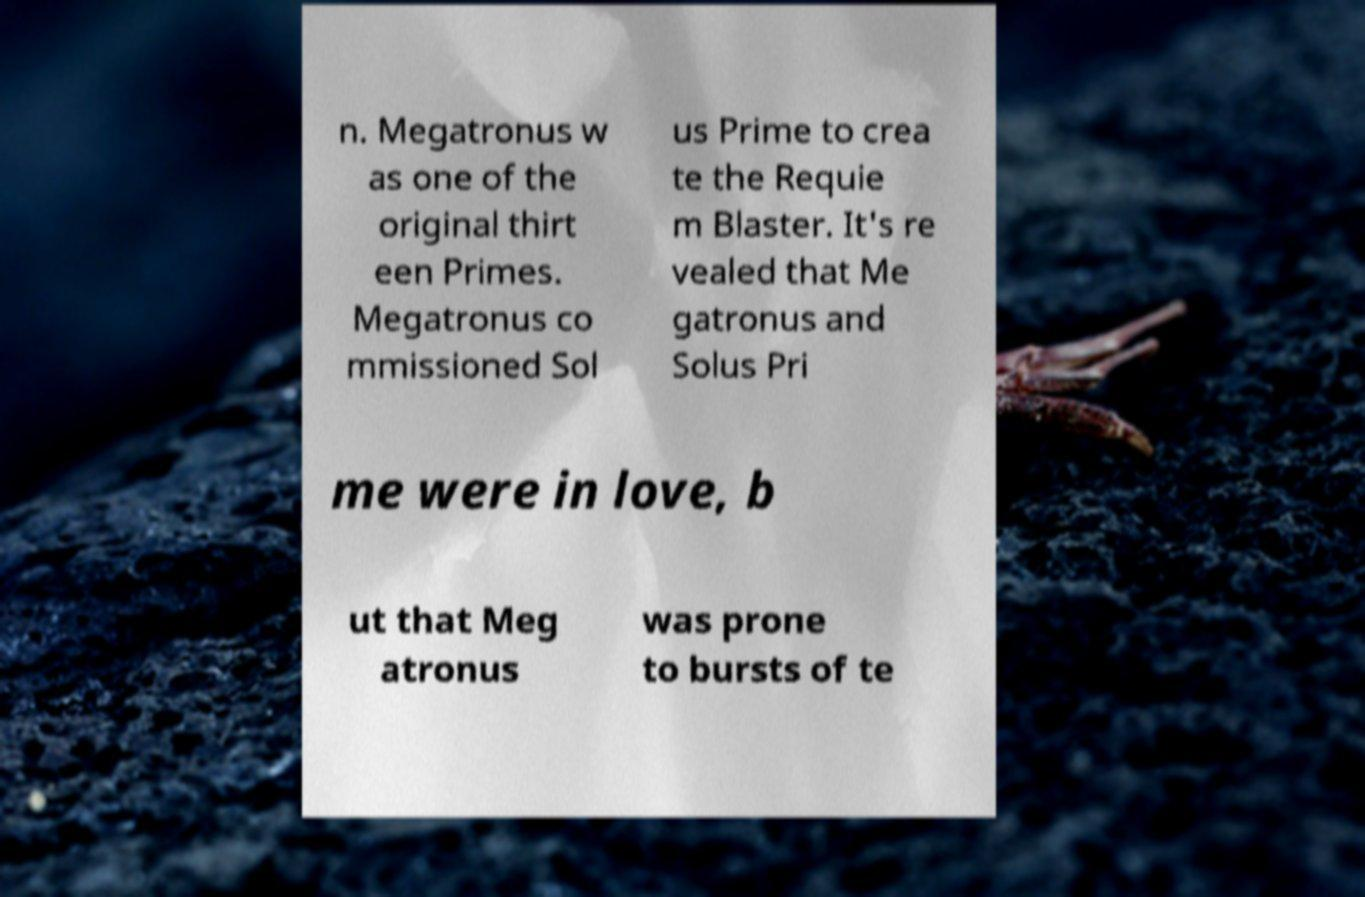What messages or text are displayed in this image? I need them in a readable, typed format. n. Megatronus w as one of the original thirt een Primes. Megatronus co mmissioned Sol us Prime to crea te the Requie m Blaster. It's re vealed that Me gatronus and Solus Pri me were in love, b ut that Meg atronus was prone to bursts of te 